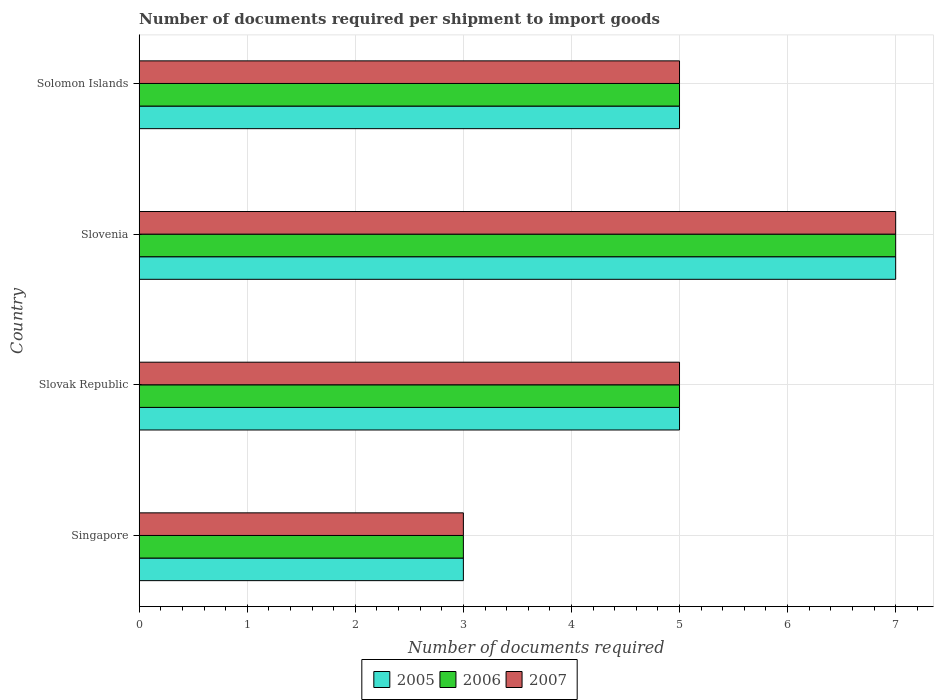How many groups of bars are there?
Provide a short and direct response. 4. Are the number of bars per tick equal to the number of legend labels?
Offer a terse response. Yes. What is the label of the 4th group of bars from the top?
Provide a succinct answer. Singapore. What is the number of documents required per shipment to import goods in 2006 in Singapore?
Give a very brief answer. 3. Across all countries, what is the minimum number of documents required per shipment to import goods in 2007?
Your response must be concise. 3. In which country was the number of documents required per shipment to import goods in 2007 maximum?
Your answer should be very brief. Slovenia. In which country was the number of documents required per shipment to import goods in 2006 minimum?
Your answer should be very brief. Singapore. What is the total number of documents required per shipment to import goods in 2005 in the graph?
Make the answer very short. 20. What is the difference between the number of documents required per shipment to import goods in 2005 in Singapore and that in Slovenia?
Your answer should be compact. -4. What is the average number of documents required per shipment to import goods in 2006 per country?
Your answer should be very brief. 5. What is the ratio of the number of documents required per shipment to import goods in 2007 in Slovenia to that in Solomon Islands?
Your answer should be very brief. 1.4. Is the number of documents required per shipment to import goods in 2007 in Slovak Republic less than that in Solomon Islands?
Provide a short and direct response. No. Is the difference between the number of documents required per shipment to import goods in 2007 in Singapore and Slovenia greater than the difference between the number of documents required per shipment to import goods in 2005 in Singapore and Slovenia?
Provide a succinct answer. No. What is the difference between the highest and the lowest number of documents required per shipment to import goods in 2007?
Keep it short and to the point. 4. What does the 3rd bar from the top in Slovak Republic represents?
Offer a terse response. 2005. What does the 3rd bar from the bottom in Singapore represents?
Offer a terse response. 2007. Is it the case that in every country, the sum of the number of documents required per shipment to import goods in 2007 and number of documents required per shipment to import goods in 2006 is greater than the number of documents required per shipment to import goods in 2005?
Your answer should be very brief. Yes. How many bars are there?
Provide a succinct answer. 12. Are all the bars in the graph horizontal?
Offer a very short reply. Yes. How many countries are there in the graph?
Your answer should be compact. 4. Are the values on the major ticks of X-axis written in scientific E-notation?
Your answer should be very brief. No. Where does the legend appear in the graph?
Your answer should be very brief. Bottom center. How many legend labels are there?
Your answer should be compact. 3. How are the legend labels stacked?
Your answer should be compact. Horizontal. What is the title of the graph?
Your answer should be compact. Number of documents required per shipment to import goods. What is the label or title of the X-axis?
Keep it short and to the point. Number of documents required. What is the label or title of the Y-axis?
Offer a terse response. Country. What is the Number of documents required of 2005 in Slovak Republic?
Offer a terse response. 5. What is the Number of documents required in 2006 in Slovak Republic?
Offer a very short reply. 5. What is the Number of documents required in 2006 in Slovenia?
Provide a succinct answer. 7. What is the Number of documents required of 2006 in Solomon Islands?
Offer a very short reply. 5. What is the Number of documents required of 2007 in Solomon Islands?
Your answer should be compact. 5. Across all countries, what is the maximum Number of documents required in 2005?
Provide a succinct answer. 7. Across all countries, what is the maximum Number of documents required of 2006?
Keep it short and to the point. 7. Across all countries, what is the maximum Number of documents required in 2007?
Offer a terse response. 7. Across all countries, what is the minimum Number of documents required in 2005?
Your response must be concise. 3. Across all countries, what is the minimum Number of documents required in 2007?
Offer a very short reply. 3. What is the total Number of documents required of 2006 in the graph?
Your answer should be very brief. 20. What is the difference between the Number of documents required in 2006 in Singapore and that in Slovak Republic?
Make the answer very short. -2. What is the difference between the Number of documents required of 2005 in Singapore and that in Slovenia?
Offer a terse response. -4. What is the difference between the Number of documents required in 2006 in Singapore and that in Slovenia?
Provide a succinct answer. -4. What is the difference between the Number of documents required in 2007 in Singapore and that in Slovenia?
Ensure brevity in your answer.  -4. What is the difference between the Number of documents required in 2005 in Singapore and that in Solomon Islands?
Your response must be concise. -2. What is the difference between the Number of documents required in 2007 in Slovak Republic and that in Slovenia?
Your answer should be very brief. -2. What is the difference between the Number of documents required in 2005 in Slovak Republic and that in Solomon Islands?
Make the answer very short. 0. What is the difference between the Number of documents required of 2006 in Slovak Republic and that in Solomon Islands?
Offer a terse response. 0. What is the difference between the Number of documents required in 2005 in Slovenia and that in Solomon Islands?
Keep it short and to the point. 2. What is the difference between the Number of documents required in 2005 in Singapore and the Number of documents required in 2006 in Slovak Republic?
Offer a very short reply. -2. What is the difference between the Number of documents required of 2005 in Singapore and the Number of documents required of 2007 in Slovak Republic?
Ensure brevity in your answer.  -2. What is the difference between the Number of documents required of 2006 in Singapore and the Number of documents required of 2007 in Slovak Republic?
Your answer should be compact. -2. What is the difference between the Number of documents required in 2005 in Singapore and the Number of documents required in 2007 in Slovenia?
Provide a short and direct response. -4. What is the difference between the Number of documents required in 2005 in Singapore and the Number of documents required in 2007 in Solomon Islands?
Offer a very short reply. -2. What is the difference between the Number of documents required of 2006 in Singapore and the Number of documents required of 2007 in Solomon Islands?
Provide a succinct answer. -2. What is the difference between the Number of documents required in 2005 in Slovak Republic and the Number of documents required in 2006 in Slovenia?
Provide a succinct answer. -2. What is the difference between the Number of documents required of 2005 in Slovak Republic and the Number of documents required of 2007 in Slovenia?
Offer a very short reply. -2. What is the difference between the Number of documents required of 2005 in Slovak Republic and the Number of documents required of 2006 in Solomon Islands?
Provide a short and direct response. 0. What is the difference between the Number of documents required in 2005 in Slovak Republic and the Number of documents required in 2007 in Solomon Islands?
Keep it short and to the point. 0. What is the difference between the Number of documents required in 2005 in Slovenia and the Number of documents required in 2006 in Solomon Islands?
Keep it short and to the point. 2. What is the difference between the Number of documents required in 2005 in Slovenia and the Number of documents required in 2007 in Solomon Islands?
Your answer should be compact. 2. What is the difference between the Number of documents required of 2006 in Slovenia and the Number of documents required of 2007 in Solomon Islands?
Keep it short and to the point. 2. What is the average Number of documents required in 2007 per country?
Offer a terse response. 5. What is the difference between the Number of documents required of 2005 and Number of documents required of 2007 in Singapore?
Provide a succinct answer. 0. What is the difference between the Number of documents required of 2006 and Number of documents required of 2007 in Singapore?
Provide a short and direct response. 0. What is the difference between the Number of documents required of 2005 and Number of documents required of 2006 in Slovak Republic?
Offer a very short reply. 0. What is the difference between the Number of documents required in 2005 and Number of documents required in 2007 in Slovak Republic?
Your response must be concise. 0. What is the difference between the Number of documents required in 2005 and Number of documents required in 2007 in Solomon Islands?
Give a very brief answer. 0. What is the difference between the Number of documents required of 2006 and Number of documents required of 2007 in Solomon Islands?
Your answer should be compact. 0. What is the ratio of the Number of documents required of 2005 in Singapore to that in Slovak Republic?
Offer a very short reply. 0.6. What is the ratio of the Number of documents required in 2006 in Singapore to that in Slovak Republic?
Provide a succinct answer. 0.6. What is the ratio of the Number of documents required in 2007 in Singapore to that in Slovak Republic?
Your answer should be compact. 0.6. What is the ratio of the Number of documents required in 2005 in Singapore to that in Slovenia?
Give a very brief answer. 0.43. What is the ratio of the Number of documents required of 2006 in Singapore to that in Slovenia?
Keep it short and to the point. 0.43. What is the ratio of the Number of documents required of 2007 in Singapore to that in Slovenia?
Your response must be concise. 0.43. What is the ratio of the Number of documents required in 2005 in Singapore to that in Solomon Islands?
Your answer should be compact. 0.6. What is the ratio of the Number of documents required in 2006 in Singapore to that in Solomon Islands?
Provide a succinct answer. 0.6. What is the ratio of the Number of documents required of 2006 in Slovak Republic to that in Slovenia?
Your answer should be very brief. 0.71. What is the ratio of the Number of documents required in 2007 in Slovak Republic to that in Solomon Islands?
Your answer should be compact. 1. What is the ratio of the Number of documents required of 2005 in Slovenia to that in Solomon Islands?
Offer a very short reply. 1.4. What is the ratio of the Number of documents required in 2007 in Slovenia to that in Solomon Islands?
Offer a very short reply. 1.4. What is the difference between the highest and the second highest Number of documents required of 2007?
Make the answer very short. 2. What is the difference between the highest and the lowest Number of documents required in 2005?
Ensure brevity in your answer.  4. What is the difference between the highest and the lowest Number of documents required of 2007?
Your response must be concise. 4. 